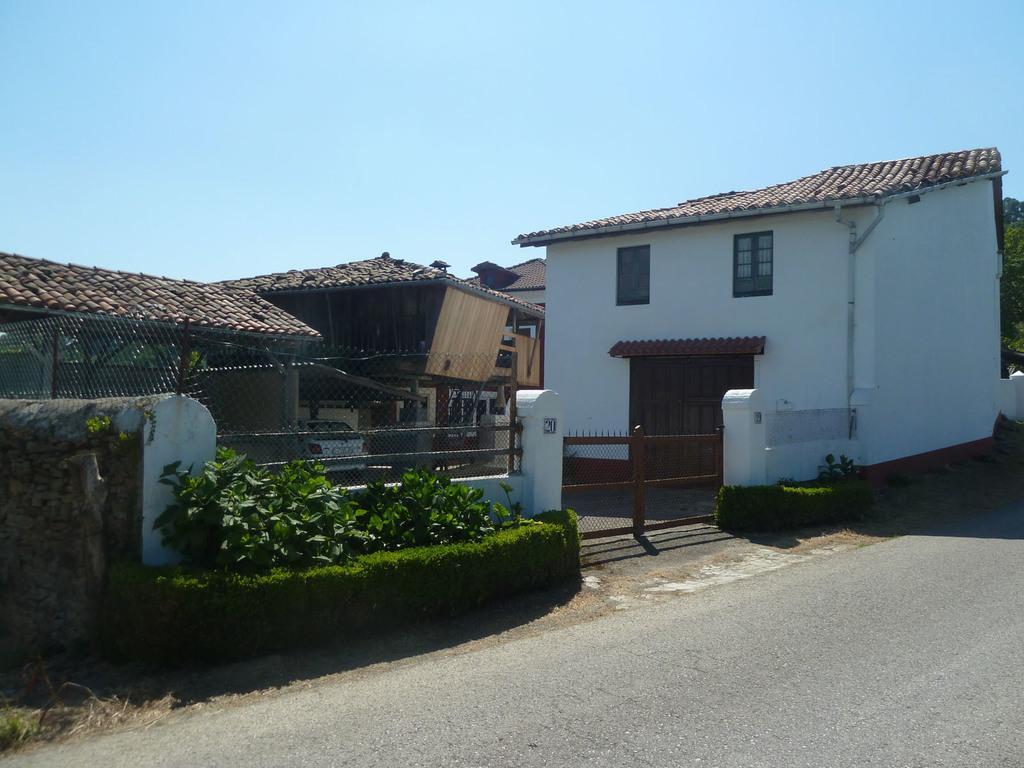Please provide a concise description of this image. In this image we can see buildings, shed, a car under the she, gate and fence to the wall, there are plants and a road in front of the building and there are trees and the sky in the background. 